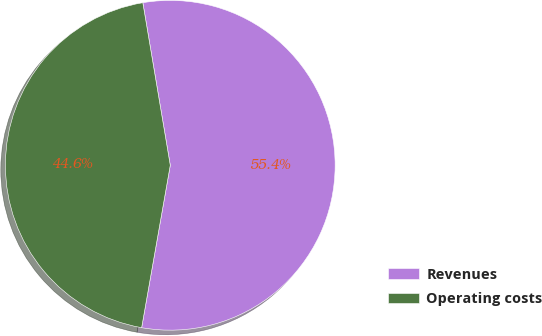<chart> <loc_0><loc_0><loc_500><loc_500><pie_chart><fcel>Revenues<fcel>Operating costs<nl><fcel>55.44%<fcel>44.56%<nl></chart> 